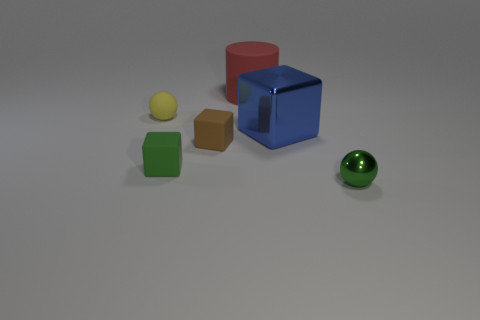The other thing that is the same color as the small shiny thing is what size?
Provide a succinct answer. Small. Do the tiny matte object in front of the brown rubber object and the metal ball have the same color?
Provide a short and direct response. Yes. How many other things are the same color as the matte sphere?
Your response must be concise. 0. Do the green cube behind the green metallic thing and the big blue cube have the same material?
Offer a very short reply. No. There is a small brown cube in front of the tiny yellow thing; what is its material?
Provide a short and direct response. Rubber. There is a object that is behind the tiny ball behind the big shiny block; what size is it?
Offer a very short reply. Large. Is there a tiny brown cube that has the same material as the large blue thing?
Provide a short and direct response. No. There is a large thing on the right side of the thing behind the small ball behind the small brown rubber thing; what shape is it?
Provide a succinct answer. Cube. There is a tiny thing right of the big red rubber object; is its color the same as the small matte block that is in front of the brown thing?
Offer a very short reply. Yes. There is a small brown matte cube; are there any things left of it?
Make the answer very short. Yes. 